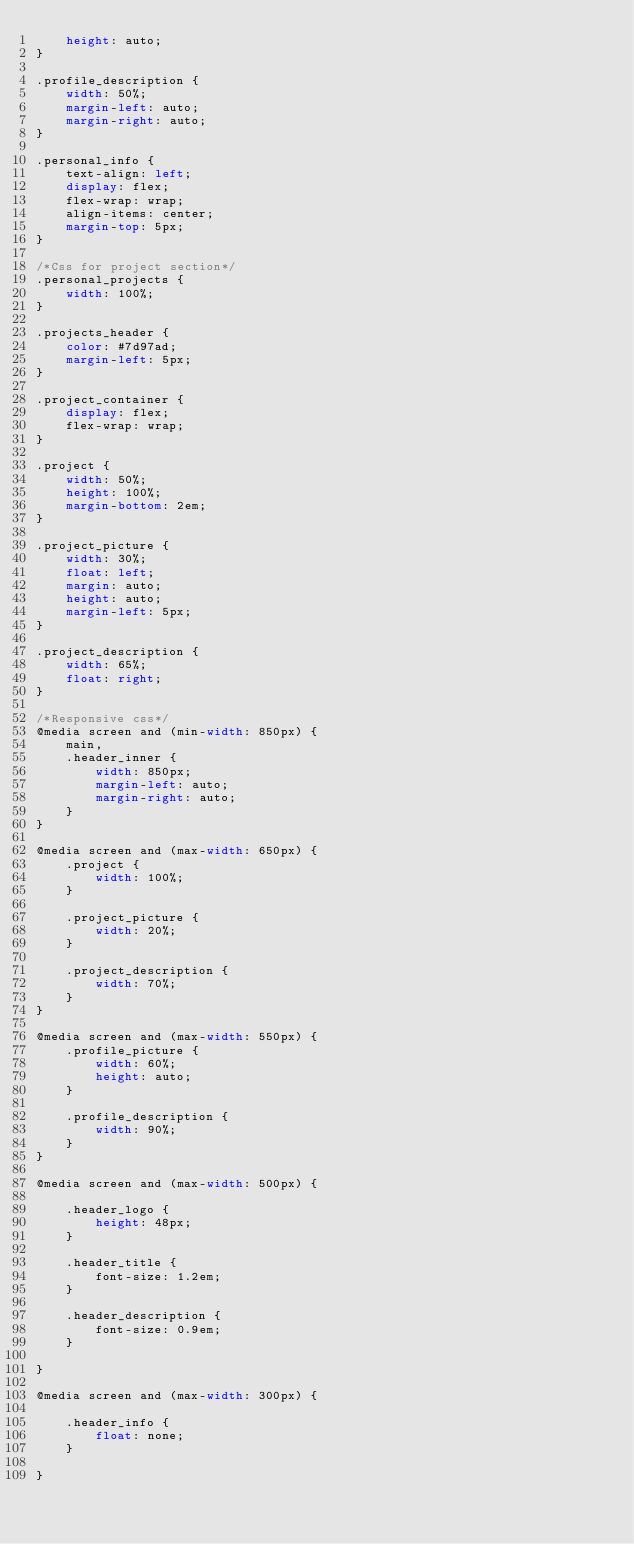<code> <loc_0><loc_0><loc_500><loc_500><_CSS_>    height: auto;
}

.profile_description {
    width: 50%;
    margin-left: auto;
    margin-right: auto;
}

.personal_info {
    text-align: left;
    display: flex;
    flex-wrap: wrap;
    align-items: center;
    margin-top: 5px;
}

/*Css for project section*/
.personal_projects {
    width: 100%;
}

.projects_header {
    color: #7d97ad;
    margin-left: 5px;
}

.project_container {
    display: flex;
    flex-wrap: wrap;
}

.project {
    width: 50%;
    height: 100%;
    margin-bottom: 2em;
}

.project_picture {
    width: 30%;
    float: left;
    margin: auto;
    height: auto;
    margin-left: 5px;
}

.project_description {
    width: 65%;
    float: right;
}

/*Responsive css*/
@media screen and (min-width: 850px) {
    main,
    .header_inner {
        width: 850px;
        margin-left: auto;
        margin-right: auto;
    }
}

@media screen and (max-width: 650px) {
    .project {
        width: 100%;
    }

    .project_picture {
        width: 20%;
    }

    .project_description {
        width: 70%;
    }
}

@media screen and (max-width: 550px) {
    .profile_picture {
        width: 60%;
        height: auto;
    }

    .profile_description {
        width: 90%;
    }
}

@media screen and (max-width: 500px) {

    .header_logo {
        height: 48px;
    }

    .header_title {
        font-size: 1.2em;
    }

    .header_description {
        font-size: 0.9em;
    }

}

@media screen and (max-width: 300px) {

    .header_info {
        float: none;
    }

}
</code> 